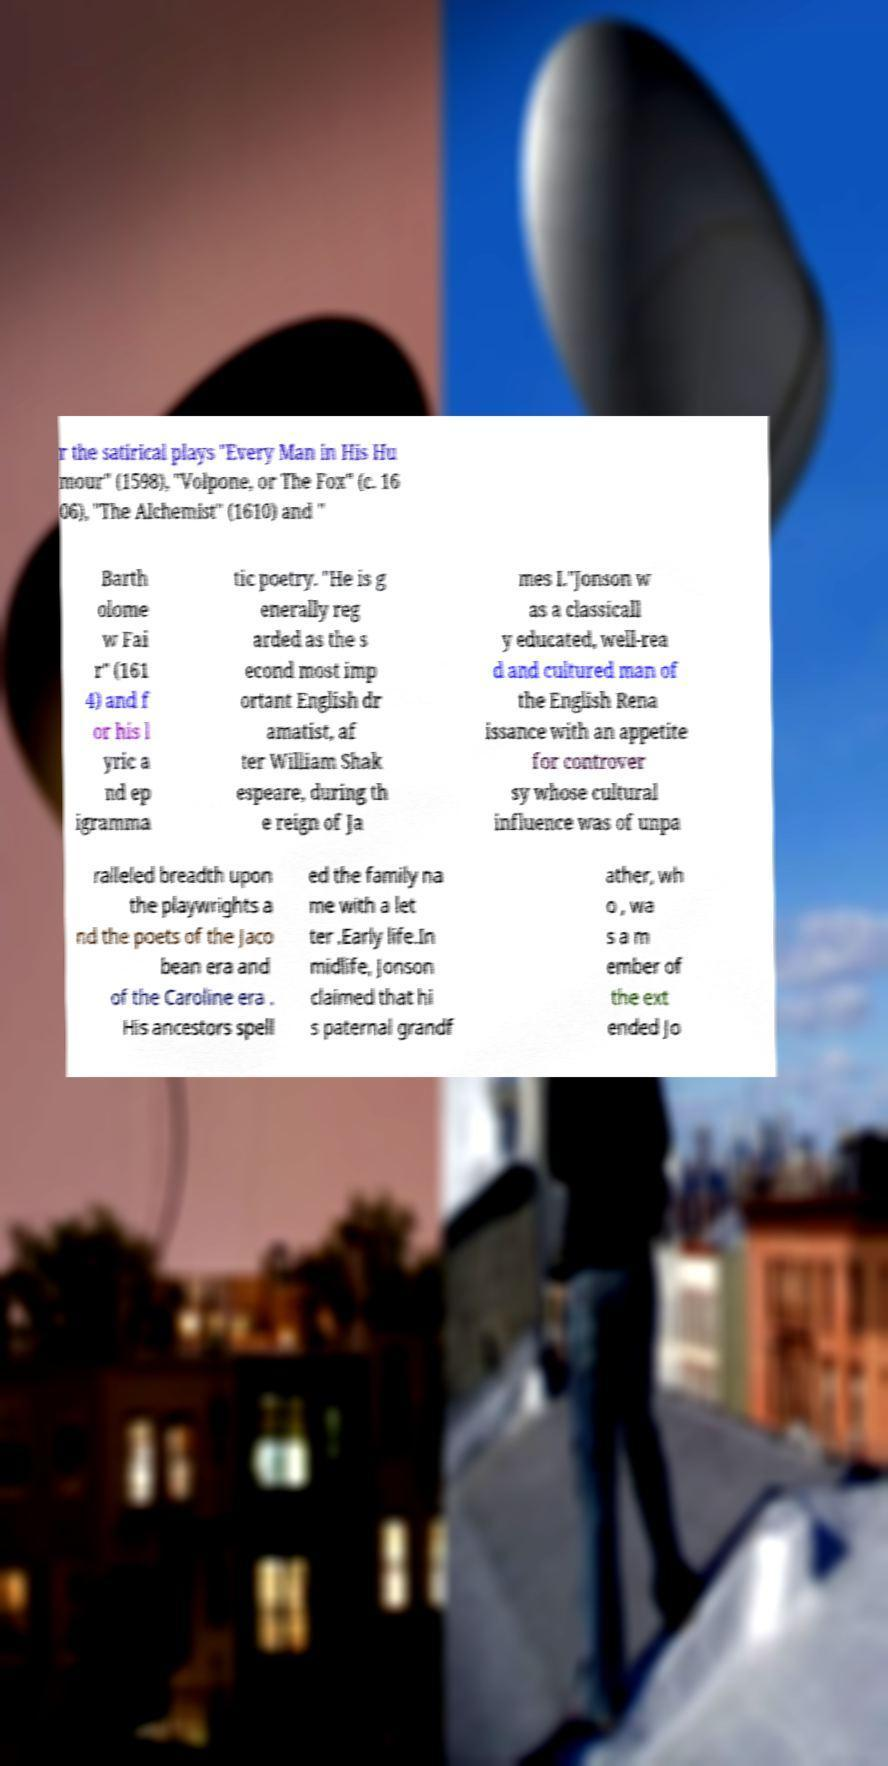Could you extract and type out the text from this image? r the satirical plays "Every Man in His Hu mour" (1598), "Volpone, or The Fox" (c. 16 06), "The Alchemist" (1610) and " Barth olome w Fai r" (161 4) and f or his l yric a nd ep igramma tic poetry. "He is g enerally reg arded as the s econd most imp ortant English dr amatist, af ter William Shak espeare, during th e reign of Ja mes I."Jonson w as a classicall y educated, well-rea d and cultured man of the English Rena issance with an appetite for controver sy whose cultural influence was of unpa ralleled breadth upon the playwrights a nd the poets of the Jaco bean era and of the Caroline era . His ancestors spell ed the family na me with a let ter .Early life.In midlife, Jonson claimed that hi s paternal grandf ather, wh o , wa s a m ember of the ext ended Jo 